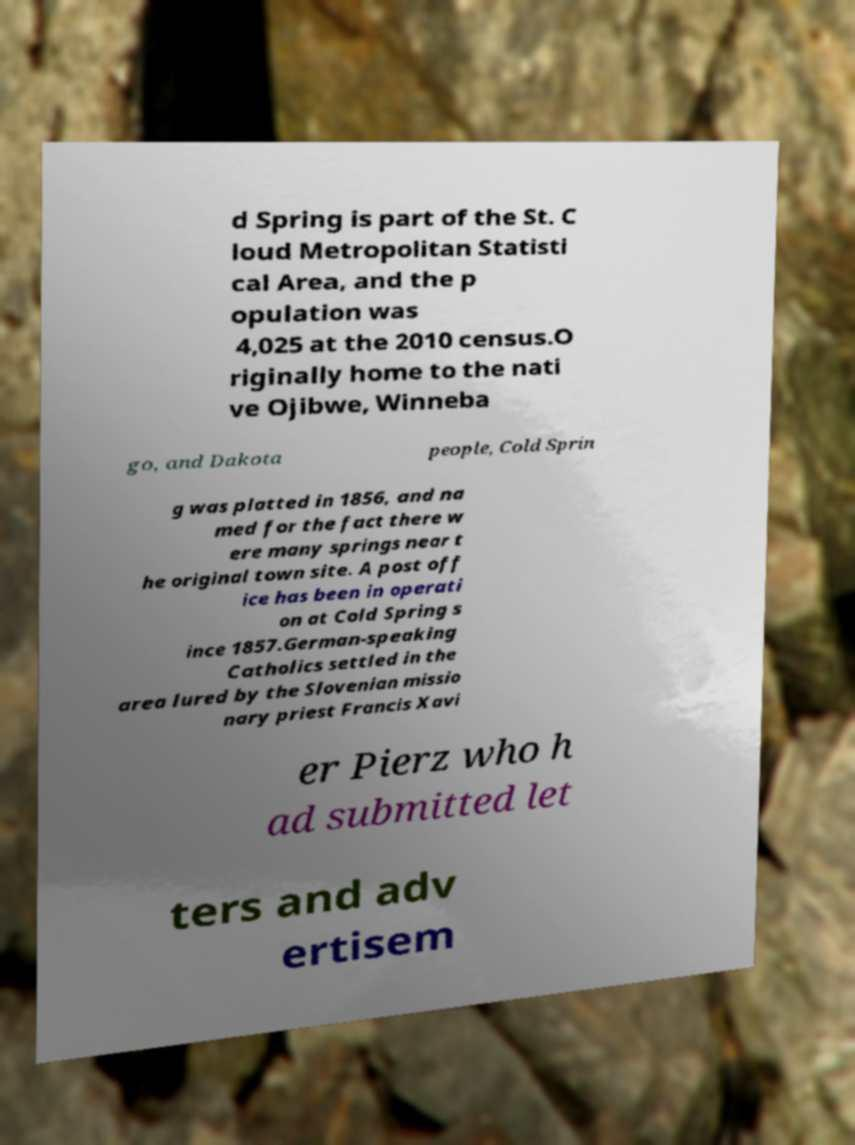Please read and relay the text visible in this image. What does it say? d Spring is part of the St. C loud Metropolitan Statisti cal Area, and the p opulation was 4,025 at the 2010 census.O riginally home to the nati ve Ojibwe, Winneba go, and Dakota people, Cold Sprin g was platted in 1856, and na med for the fact there w ere many springs near t he original town site. A post off ice has been in operati on at Cold Spring s ince 1857.German-speaking Catholics settled in the area lured by the Slovenian missio nary priest Francis Xavi er Pierz who h ad submitted let ters and adv ertisem 